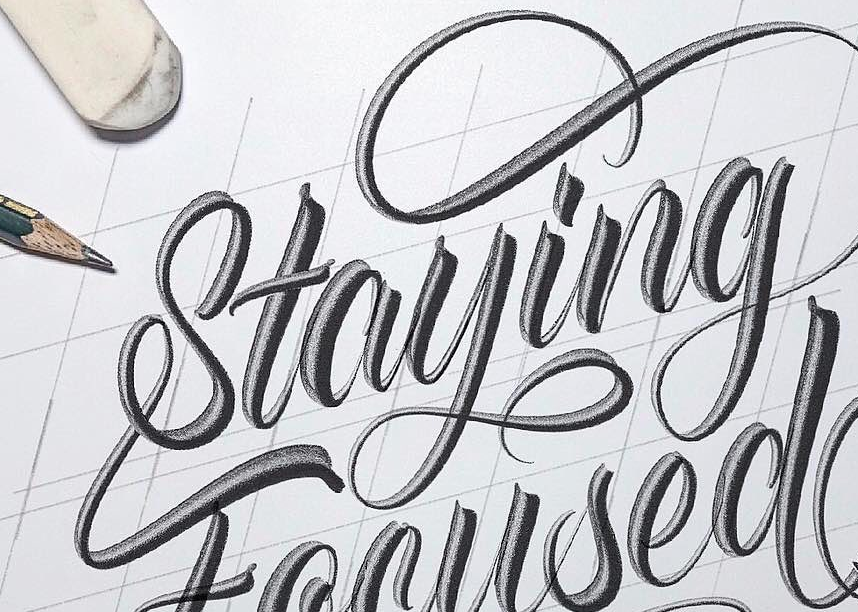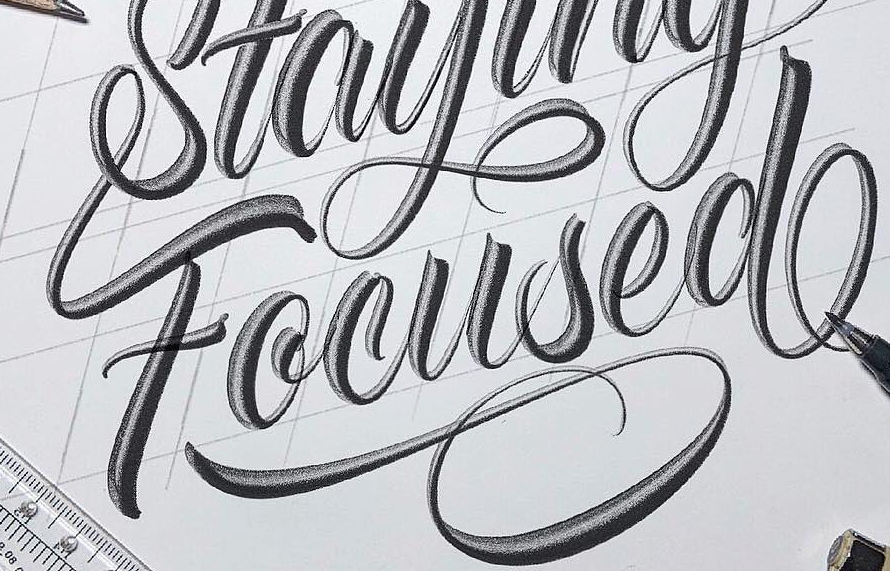Read the text content from these images in order, separated by a semicolon. Staying; Focused 